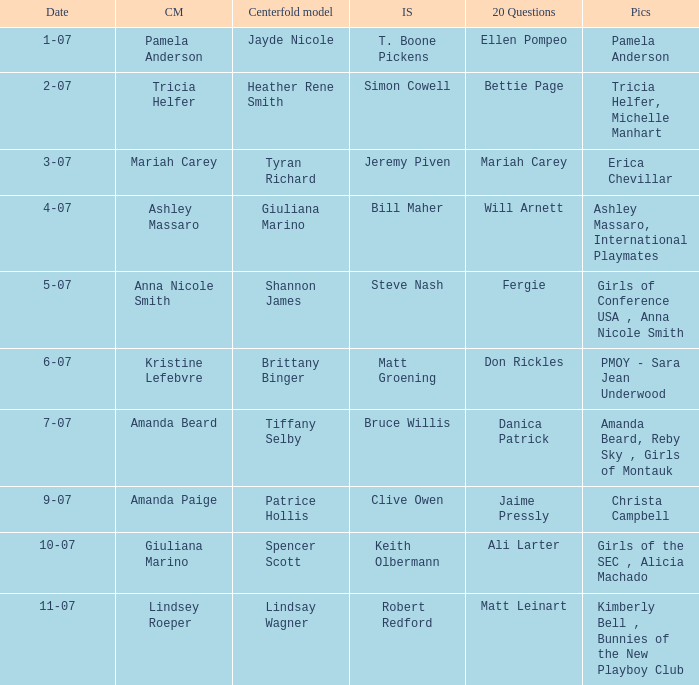Who was the cover model when the issue's pictorials was pmoy - sara jean underwood? Kristine Lefebvre. Would you mind parsing the complete table? {'header': ['Date', 'CM', 'Centerfold model', 'IS', '20 Questions', 'Pics'], 'rows': [['1-07', 'Pamela Anderson', 'Jayde Nicole', 'T. Boone Pickens', 'Ellen Pompeo', 'Pamela Anderson'], ['2-07', 'Tricia Helfer', 'Heather Rene Smith', 'Simon Cowell', 'Bettie Page', 'Tricia Helfer, Michelle Manhart'], ['3-07', 'Mariah Carey', 'Tyran Richard', 'Jeremy Piven', 'Mariah Carey', 'Erica Chevillar'], ['4-07', 'Ashley Massaro', 'Giuliana Marino', 'Bill Maher', 'Will Arnett', 'Ashley Massaro, International Playmates'], ['5-07', 'Anna Nicole Smith', 'Shannon James', 'Steve Nash', 'Fergie', 'Girls of Conference USA , Anna Nicole Smith'], ['6-07', 'Kristine Lefebvre', 'Brittany Binger', 'Matt Groening', 'Don Rickles', 'PMOY - Sara Jean Underwood'], ['7-07', 'Amanda Beard', 'Tiffany Selby', 'Bruce Willis', 'Danica Patrick', 'Amanda Beard, Reby Sky , Girls of Montauk'], ['9-07', 'Amanda Paige', 'Patrice Hollis', 'Clive Owen', 'Jaime Pressly', 'Christa Campbell'], ['10-07', 'Giuliana Marino', 'Spencer Scott', 'Keith Olbermann', 'Ali Larter', 'Girls of the SEC , Alicia Machado'], ['11-07', 'Lindsey Roeper', 'Lindsay Wagner', 'Robert Redford', 'Matt Leinart', 'Kimberly Bell , Bunnies of the New Playboy Club']]} 